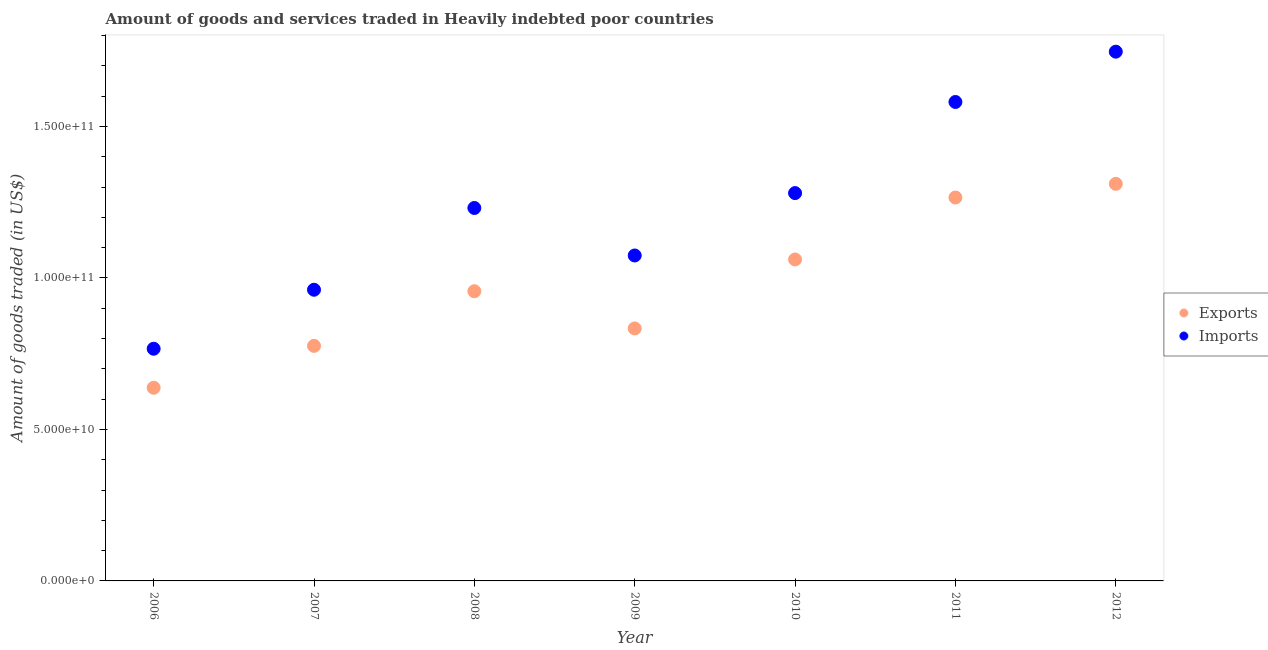What is the amount of goods imported in 2012?
Your answer should be very brief. 1.75e+11. Across all years, what is the maximum amount of goods imported?
Ensure brevity in your answer.  1.75e+11. Across all years, what is the minimum amount of goods exported?
Make the answer very short. 6.38e+1. In which year was the amount of goods exported maximum?
Offer a very short reply. 2012. What is the total amount of goods exported in the graph?
Your answer should be compact. 6.84e+11. What is the difference between the amount of goods imported in 2006 and that in 2011?
Keep it short and to the point. -8.14e+1. What is the difference between the amount of goods imported in 2011 and the amount of goods exported in 2010?
Your response must be concise. 5.20e+1. What is the average amount of goods exported per year?
Offer a very short reply. 9.77e+1. In the year 2011, what is the difference between the amount of goods exported and amount of goods imported?
Your response must be concise. -3.15e+1. What is the ratio of the amount of goods exported in 2010 to that in 2011?
Your response must be concise. 0.84. Is the difference between the amount of goods imported in 2008 and 2010 greater than the difference between the amount of goods exported in 2008 and 2010?
Provide a short and direct response. Yes. What is the difference between the highest and the second highest amount of goods imported?
Your response must be concise. 1.66e+1. What is the difference between the highest and the lowest amount of goods exported?
Offer a terse response. 6.73e+1. In how many years, is the amount of goods exported greater than the average amount of goods exported taken over all years?
Ensure brevity in your answer.  3. Is the sum of the amount of goods imported in 2008 and 2011 greater than the maximum amount of goods exported across all years?
Your answer should be compact. Yes. Is the amount of goods imported strictly less than the amount of goods exported over the years?
Keep it short and to the point. No. How many dotlines are there?
Keep it short and to the point. 2. Are the values on the major ticks of Y-axis written in scientific E-notation?
Your response must be concise. Yes. Does the graph contain any zero values?
Provide a short and direct response. No. Where does the legend appear in the graph?
Offer a very short reply. Center right. How many legend labels are there?
Provide a succinct answer. 2. How are the legend labels stacked?
Offer a terse response. Vertical. What is the title of the graph?
Make the answer very short. Amount of goods and services traded in Heavily indebted poor countries. Does "Residents" appear as one of the legend labels in the graph?
Provide a succinct answer. No. What is the label or title of the Y-axis?
Give a very brief answer. Amount of goods traded (in US$). What is the Amount of goods traded (in US$) in Exports in 2006?
Ensure brevity in your answer.  6.38e+1. What is the Amount of goods traded (in US$) of Imports in 2006?
Provide a short and direct response. 7.66e+1. What is the Amount of goods traded (in US$) of Exports in 2007?
Your answer should be compact. 7.76e+1. What is the Amount of goods traded (in US$) in Imports in 2007?
Provide a short and direct response. 9.61e+1. What is the Amount of goods traded (in US$) in Exports in 2008?
Provide a succinct answer. 9.56e+1. What is the Amount of goods traded (in US$) in Imports in 2008?
Provide a succinct answer. 1.23e+11. What is the Amount of goods traded (in US$) in Exports in 2009?
Your response must be concise. 8.33e+1. What is the Amount of goods traded (in US$) of Imports in 2009?
Keep it short and to the point. 1.07e+11. What is the Amount of goods traded (in US$) in Exports in 2010?
Provide a succinct answer. 1.06e+11. What is the Amount of goods traded (in US$) of Imports in 2010?
Give a very brief answer. 1.28e+11. What is the Amount of goods traded (in US$) of Exports in 2011?
Provide a short and direct response. 1.27e+11. What is the Amount of goods traded (in US$) of Imports in 2011?
Make the answer very short. 1.58e+11. What is the Amount of goods traded (in US$) of Exports in 2012?
Your response must be concise. 1.31e+11. What is the Amount of goods traded (in US$) of Imports in 2012?
Ensure brevity in your answer.  1.75e+11. Across all years, what is the maximum Amount of goods traded (in US$) in Exports?
Your answer should be very brief. 1.31e+11. Across all years, what is the maximum Amount of goods traded (in US$) in Imports?
Keep it short and to the point. 1.75e+11. Across all years, what is the minimum Amount of goods traded (in US$) of Exports?
Provide a short and direct response. 6.38e+1. Across all years, what is the minimum Amount of goods traded (in US$) in Imports?
Give a very brief answer. 7.66e+1. What is the total Amount of goods traded (in US$) of Exports in the graph?
Provide a short and direct response. 6.84e+11. What is the total Amount of goods traded (in US$) in Imports in the graph?
Ensure brevity in your answer.  8.64e+11. What is the difference between the Amount of goods traded (in US$) in Exports in 2006 and that in 2007?
Provide a succinct answer. -1.38e+1. What is the difference between the Amount of goods traded (in US$) of Imports in 2006 and that in 2007?
Ensure brevity in your answer.  -1.95e+1. What is the difference between the Amount of goods traded (in US$) in Exports in 2006 and that in 2008?
Make the answer very short. -3.19e+1. What is the difference between the Amount of goods traded (in US$) of Imports in 2006 and that in 2008?
Offer a very short reply. -4.65e+1. What is the difference between the Amount of goods traded (in US$) of Exports in 2006 and that in 2009?
Make the answer very short. -1.96e+1. What is the difference between the Amount of goods traded (in US$) of Imports in 2006 and that in 2009?
Provide a short and direct response. -3.08e+1. What is the difference between the Amount of goods traded (in US$) in Exports in 2006 and that in 2010?
Offer a very short reply. -4.23e+1. What is the difference between the Amount of goods traded (in US$) in Imports in 2006 and that in 2010?
Keep it short and to the point. -5.14e+1. What is the difference between the Amount of goods traded (in US$) in Exports in 2006 and that in 2011?
Ensure brevity in your answer.  -6.28e+1. What is the difference between the Amount of goods traded (in US$) in Imports in 2006 and that in 2011?
Keep it short and to the point. -8.14e+1. What is the difference between the Amount of goods traded (in US$) of Exports in 2006 and that in 2012?
Give a very brief answer. -6.73e+1. What is the difference between the Amount of goods traded (in US$) of Imports in 2006 and that in 2012?
Give a very brief answer. -9.80e+1. What is the difference between the Amount of goods traded (in US$) in Exports in 2007 and that in 2008?
Your answer should be very brief. -1.80e+1. What is the difference between the Amount of goods traded (in US$) in Imports in 2007 and that in 2008?
Offer a terse response. -2.70e+1. What is the difference between the Amount of goods traded (in US$) of Exports in 2007 and that in 2009?
Your answer should be compact. -5.75e+09. What is the difference between the Amount of goods traded (in US$) in Imports in 2007 and that in 2009?
Provide a short and direct response. -1.13e+1. What is the difference between the Amount of goods traded (in US$) in Exports in 2007 and that in 2010?
Provide a succinct answer. -2.85e+1. What is the difference between the Amount of goods traded (in US$) of Imports in 2007 and that in 2010?
Provide a short and direct response. -3.19e+1. What is the difference between the Amount of goods traded (in US$) of Exports in 2007 and that in 2011?
Your answer should be compact. -4.90e+1. What is the difference between the Amount of goods traded (in US$) of Imports in 2007 and that in 2011?
Keep it short and to the point. -6.20e+1. What is the difference between the Amount of goods traded (in US$) of Exports in 2007 and that in 2012?
Provide a succinct answer. -5.35e+1. What is the difference between the Amount of goods traded (in US$) in Imports in 2007 and that in 2012?
Ensure brevity in your answer.  -7.86e+1. What is the difference between the Amount of goods traded (in US$) in Exports in 2008 and that in 2009?
Provide a short and direct response. 1.23e+1. What is the difference between the Amount of goods traded (in US$) of Imports in 2008 and that in 2009?
Your response must be concise. 1.57e+1. What is the difference between the Amount of goods traded (in US$) of Exports in 2008 and that in 2010?
Provide a succinct answer. -1.05e+1. What is the difference between the Amount of goods traded (in US$) in Imports in 2008 and that in 2010?
Offer a very short reply. -4.91e+09. What is the difference between the Amount of goods traded (in US$) of Exports in 2008 and that in 2011?
Make the answer very short. -3.09e+1. What is the difference between the Amount of goods traded (in US$) in Imports in 2008 and that in 2011?
Your response must be concise. -3.50e+1. What is the difference between the Amount of goods traded (in US$) in Exports in 2008 and that in 2012?
Offer a terse response. -3.54e+1. What is the difference between the Amount of goods traded (in US$) of Imports in 2008 and that in 2012?
Your response must be concise. -5.16e+1. What is the difference between the Amount of goods traded (in US$) in Exports in 2009 and that in 2010?
Provide a succinct answer. -2.28e+1. What is the difference between the Amount of goods traded (in US$) in Imports in 2009 and that in 2010?
Provide a succinct answer. -2.06e+1. What is the difference between the Amount of goods traded (in US$) of Exports in 2009 and that in 2011?
Ensure brevity in your answer.  -4.32e+1. What is the difference between the Amount of goods traded (in US$) in Imports in 2009 and that in 2011?
Provide a short and direct response. -5.07e+1. What is the difference between the Amount of goods traded (in US$) in Exports in 2009 and that in 2012?
Provide a succinct answer. -4.77e+1. What is the difference between the Amount of goods traded (in US$) of Imports in 2009 and that in 2012?
Offer a terse response. -6.73e+1. What is the difference between the Amount of goods traded (in US$) of Exports in 2010 and that in 2011?
Your answer should be compact. -2.04e+1. What is the difference between the Amount of goods traded (in US$) of Imports in 2010 and that in 2011?
Ensure brevity in your answer.  -3.01e+1. What is the difference between the Amount of goods traded (in US$) of Exports in 2010 and that in 2012?
Offer a very short reply. -2.50e+1. What is the difference between the Amount of goods traded (in US$) in Imports in 2010 and that in 2012?
Give a very brief answer. -4.67e+1. What is the difference between the Amount of goods traded (in US$) of Exports in 2011 and that in 2012?
Your answer should be very brief. -4.52e+09. What is the difference between the Amount of goods traded (in US$) in Imports in 2011 and that in 2012?
Your answer should be compact. -1.66e+1. What is the difference between the Amount of goods traded (in US$) of Exports in 2006 and the Amount of goods traded (in US$) of Imports in 2007?
Your answer should be very brief. -3.23e+1. What is the difference between the Amount of goods traded (in US$) of Exports in 2006 and the Amount of goods traded (in US$) of Imports in 2008?
Your answer should be very brief. -5.93e+1. What is the difference between the Amount of goods traded (in US$) in Exports in 2006 and the Amount of goods traded (in US$) in Imports in 2009?
Your answer should be very brief. -4.37e+1. What is the difference between the Amount of goods traded (in US$) in Exports in 2006 and the Amount of goods traded (in US$) in Imports in 2010?
Make the answer very short. -6.42e+1. What is the difference between the Amount of goods traded (in US$) of Exports in 2006 and the Amount of goods traded (in US$) of Imports in 2011?
Give a very brief answer. -9.43e+1. What is the difference between the Amount of goods traded (in US$) of Exports in 2006 and the Amount of goods traded (in US$) of Imports in 2012?
Give a very brief answer. -1.11e+11. What is the difference between the Amount of goods traded (in US$) in Exports in 2007 and the Amount of goods traded (in US$) in Imports in 2008?
Your response must be concise. -4.55e+1. What is the difference between the Amount of goods traded (in US$) in Exports in 2007 and the Amount of goods traded (in US$) in Imports in 2009?
Keep it short and to the point. -2.98e+1. What is the difference between the Amount of goods traded (in US$) in Exports in 2007 and the Amount of goods traded (in US$) in Imports in 2010?
Your response must be concise. -5.04e+1. What is the difference between the Amount of goods traded (in US$) of Exports in 2007 and the Amount of goods traded (in US$) of Imports in 2011?
Your answer should be compact. -8.05e+1. What is the difference between the Amount of goods traded (in US$) of Exports in 2007 and the Amount of goods traded (in US$) of Imports in 2012?
Keep it short and to the point. -9.71e+1. What is the difference between the Amount of goods traded (in US$) in Exports in 2008 and the Amount of goods traded (in US$) in Imports in 2009?
Your answer should be compact. -1.18e+1. What is the difference between the Amount of goods traded (in US$) in Exports in 2008 and the Amount of goods traded (in US$) in Imports in 2010?
Keep it short and to the point. -3.24e+1. What is the difference between the Amount of goods traded (in US$) of Exports in 2008 and the Amount of goods traded (in US$) of Imports in 2011?
Give a very brief answer. -6.25e+1. What is the difference between the Amount of goods traded (in US$) of Exports in 2008 and the Amount of goods traded (in US$) of Imports in 2012?
Provide a succinct answer. -7.91e+1. What is the difference between the Amount of goods traded (in US$) in Exports in 2009 and the Amount of goods traded (in US$) in Imports in 2010?
Your answer should be very brief. -4.47e+1. What is the difference between the Amount of goods traded (in US$) in Exports in 2009 and the Amount of goods traded (in US$) in Imports in 2011?
Give a very brief answer. -7.47e+1. What is the difference between the Amount of goods traded (in US$) in Exports in 2009 and the Amount of goods traded (in US$) in Imports in 2012?
Offer a terse response. -9.13e+1. What is the difference between the Amount of goods traded (in US$) of Exports in 2010 and the Amount of goods traded (in US$) of Imports in 2011?
Give a very brief answer. -5.20e+1. What is the difference between the Amount of goods traded (in US$) in Exports in 2010 and the Amount of goods traded (in US$) in Imports in 2012?
Ensure brevity in your answer.  -6.86e+1. What is the difference between the Amount of goods traded (in US$) in Exports in 2011 and the Amount of goods traded (in US$) in Imports in 2012?
Your response must be concise. -4.81e+1. What is the average Amount of goods traded (in US$) of Exports per year?
Offer a very short reply. 9.77e+1. What is the average Amount of goods traded (in US$) in Imports per year?
Make the answer very short. 1.23e+11. In the year 2006, what is the difference between the Amount of goods traded (in US$) of Exports and Amount of goods traded (in US$) of Imports?
Offer a very short reply. -1.29e+1. In the year 2007, what is the difference between the Amount of goods traded (in US$) in Exports and Amount of goods traded (in US$) in Imports?
Your response must be concise. -1.85e+1. In the year 2008, what is the difference between the Amount of goods traded (in US$) in Exports and Amount of goods traded (in US$) in Imports?
Ensure brevity in your answer.  -2.75e+1. In the year 2009, what is the difference between the Amount of goods traded (in US$) of Exports and Amount of goods traded (in US$) of Imports?
Give a very brief answer. -2.41e+1. In the year 2010, what is the difference between the Amount of goods traded (in US$) in Exports and Amount of goods traded (in US$) in Imports?
Provide a short and direct response. -2.19e+1. In the year 2011, what is the difference between the Amount of goods traded (in US$) in Exports and Amount of goods traded (in US$) in Imports?
Your answer should be compact. -3.15e+1. In the year 2012, what is the difference between the Amount of goods traded (in US$) in Exports and Amount of goods traded (in US$) in Imports?
Keep it short and to the point. -4.36e+1. What is the ratio of the Amount of goods traded (in US$) in Exports in 2006 to that in 2007?
Give a very brief answer. 0.82. What is the ratio of the Amount of goods traded (in US$) of Imports in 2006 to that in 2007?
Give a very brief answer. 0.8. What is the ratio of the Amount of goods traded (in US$) in Exports in 2006 to that in 2008?
Offer a terse response. 0.67. What is the ratio of the Amount of goods traded (in US$) of Imports in 2006 to that in 2008?
Your response must be concise. 0.62. What is the ratio of the Amount of goods traded (in US$) in Exports in 2006 to that in 2009?
Provide a short and direct response. 0.77. What is the ratio of the Amount of goods traded (in US$) in Imports in 2006 to that in 2009?
Your response must be concise. 0.71. What is the ratio of the Amount of goods traded (in US$) in Exports in 2006 to that in 2010?
Offer a terse response. 0.6. What is the ratio of the Amount of goods traded (in US$) in Imports in 2006 to that in 2010?
Give a very brief answer. 0.6. What is the ratio of the Amount of goods traded (in US$) of Exports in 2006 to that in 2011?
Your response must be concise. 0.5. What is the ratio of the Amount of goods traded (in US$) in Imports in 2006 to that in 2011?
Provide a succinct answer. 0.48. What is the ratio of the Amount of goods traded (in US$) of Exports in 2006 to that in 2012?
Offer a very short reply. 0.49. What is the ratio of the Amount of goods traded (in US$) in Imports in 2006 to that in 2012?
Make the answer very short. 0.44. What is the ratio of the Amount of goods traded (in US$) of Exports in 2007 to that in 2008?
Make the answer very short. 0.81. What is the ratio of the Amount of goods traded (in US$) in Imports in 2007 to that in 2008?
Your answer should be compact. 0.78. What is the ratio of the Amount of goods traded (in US$) of Imports in 2007 to that in 2009?
Give a very brief answer. 0.89. What is the ratio of the Amount of goods traded (in US$) in Exports in 2007 to that in 2010?
Make the answer very short. 0.73. What is the ratio of the Amount of goods traded (in US$) of Imports in 2007 to that in 2010?
Provide a succinct answer. 0.75. What is the ratio of the Amount of goods traded (in US$) in Exports in 2007 to that in 2011?
Offer a very short reply. 0.61. What is the ratio of the Amount of goods traded (in US$) of Imports in 2007 to that in 2011?
Provide a succinct answer. 0.61. What is the ratio of the Amount of goods traded (in US$) of Exports in 2007 to that in 2012?
Provide a succinct answer. 0.59. What is the ratio of the Amount of goods traded (in US$) of Imports in 2007 to that in 2012?
Give a very brief answer. 0.55. What is the ratio of the Amount of goods traded (in US$) in Exports in 2008 to that in 2009?
Ensure brevity in your answer.  1.15. What is the ratio of the Amount of goods traded (in US$) of Imports in 2008 to that in 2009?
Give a very brief answer. 1.15. What is the ratio of the Amount of goods traded (in US$) of Exports in 2008 to that in 2010?
Provide a succinct answer. 0.9. What is the ratio of the Amount of goods traded (in US$) of Imports in 2008 to that in 2010?
Keep it short and to the point. 0.96. What is the ratio of the Amount of goods traded (in US$) of Exports in 2008 to that in 2011?
Offer a terse response. 0.76. What is the ratio of the Amount of goods traded (in US$) in Imports in 2008 to that in 2011?
Provide a succinct answer. 0.78. What is the ratio of the Amount of goods traded (in US$) in Exports in 2008 to that in 2012?
Make the answer very short. 0.73. What is the ratio of the Amount of goods traded (in US$) of Imports in 2008 to that in 2012?
Offer a terse response. 0.7. What is the ratio of the Amount of goods traded (in US$) of Exports in 2009 to that in 2010?
Provide a short and direct response. 0.79. What is the ratio of the Amount of goods traded (in US$) in Imports in 2009 to that in 2010?
Offer a terse response. 0.84. What is the ratio of the Amount of goods traded (in US$) of Exports in 2009 to that in 2011?
Provide a succinct answer. 0.66. What is the ratio of the Amount of goods traded (in US$) in Imports in 2009 to that in 2011?
Make the answer very short. 0.68. What is the ratio of the Amount of goods traded (in US$) in Exports in 2009 to that in 2012?
Your answer should be compact. 0.64. What is the ratio of the Amount of goods traded (in US$) in Imports in 2009 to that in 2012?
Ensure brevity in your answer.  0.61. What is the ratio of the Amount of goods traded (in US$) of Exports in 2010 to that in 2011?
Your response must be concise. 0.84. What is the ratio of the Amount of goods traded (in US$) in Imports in 2010 to that in 2011?
Offer a very short reply. 0.81. What is the ratio of the Amount of goods traded (in US$) of Exports in 2010 to that in 2012?
Provide a short and direct response. 0.81. What is the ratio of the Amount of goods traded (in US$) of Imports in 2010 to that in 2012?
Ensure brevity in your answer.  0.73. What is the ratio of the Amount of goods traded (in US$) of Exports in 2011 to that in 2012?
Offer a very short reply. 0.97. What is the ratio of the Amount of goods traded (in US$) of Imports in 2011 to that in 2012?
Make the answer very short. 0.91. What is the difference between the highest and the second highest Amount of goods traded (in US$) in Exports?
Make the answer very short. 4.52e+09. What is the difference between the highest and the second highest Amount of goods traded (in US$) of Imports?
Your answer should be compact. 1.66e+1. What is the difference between the highest and the lowest Amount of goods traded (in US$) of Exports?
Give a very brief answer. 6.73e+1. What is the difference between the highest and the lowest Amount of goods traded (in US$) in Imports?
Your answer should be compact. 9.80e+1. 